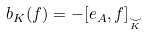Convert formula to latex. <formula><loc_0><loc_0><loc_500><loc_500>b _ { K } ( f ) = - [ e _ { A } , f ] _ { \underset { K } { \smile } }</formula> 